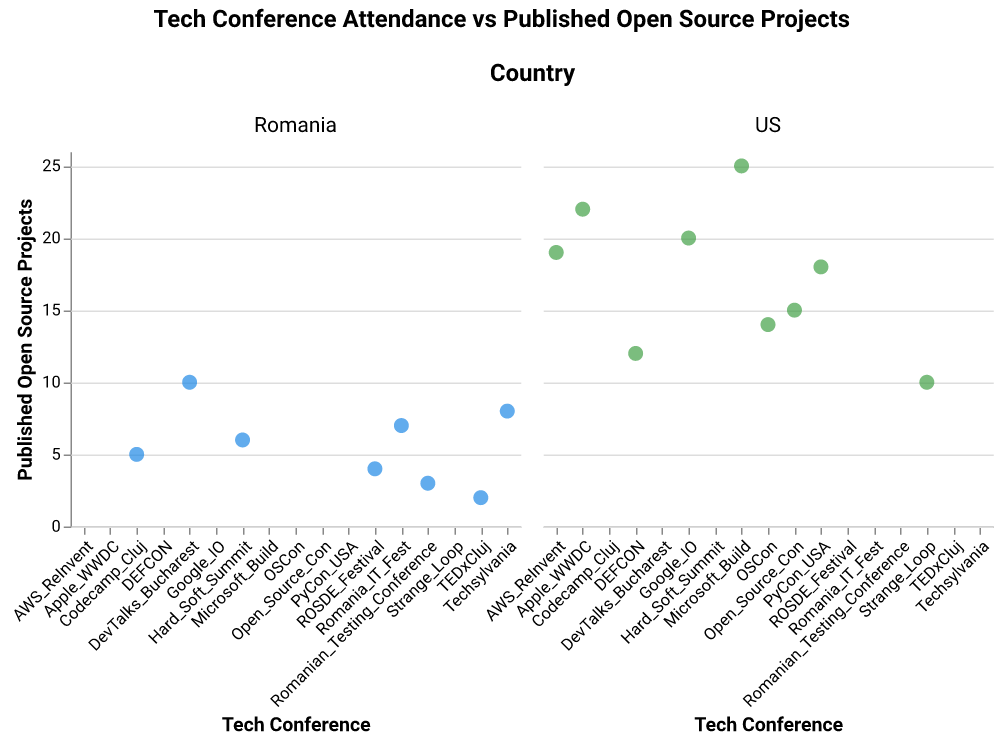Which Romanian conference has the highest number of published open-source projects? To identify the Romanian conference with the highest number of published open-source projects, observe the data points in the Romania subplot and find the one with the maximum y-value.
Answer: DevTalks Bucharest What is the total number of published open-source projects across all US conferences? Sum the y-values of all data points in the US subplot: 15 + 20 + 18 + 25 + 22 + 19 + 10 + 12 + 14 = 155
Answer: 155 How many conferences in Romania have published more than 5 open-source projects? Count the number of data points in the Romania subplot where the y-value is greater than 5: Romania_IT_Fest, DevTalks_Bucharest, Techsylvania, Hard_Soft_Summit.
Answer: 4 Which country has the conference with the most published open-source projects? Compare the maximum y-values in both country subplots: US has a maximum of 25 and Romania has a maximum of 10. Therefore, the US has the conference with the most published open-source projects.
Answer: US What is the difference in the number of published open-source projects between the highest and lowest conferences in the US? In the US subplot, the conference with the highest number of published open-source projects is Microsoft Build (25), and the lowest is Open Source Con (10). The difference is 25 - 10.
Answer: 15 On average, how many open-source projects do conferences in Romania publish? Sum the y-values of all Romanian conferences: 7 + 10 + 5 + 2 + 8 + 6 + 3 + 4 = 45. Divide by the number of conferences: 45 / 8.
Answer: 5.625 Which conference has more published open-source projects: TEDxCluj or AWS ReInvent? Compare the y-values of TEDxCluj (2) in Romania to AWS ReInvent (19) in the US.
Answer: AWS ReInvent Is there a larger variability in the number of published open-source projects in Romanian conferences or US conferences? Assess variability: The US subplot shows a larger range of values (from 10 to 25) compared to Romania (from 2 to 10), indicating more variability in the US.
Answer: US 